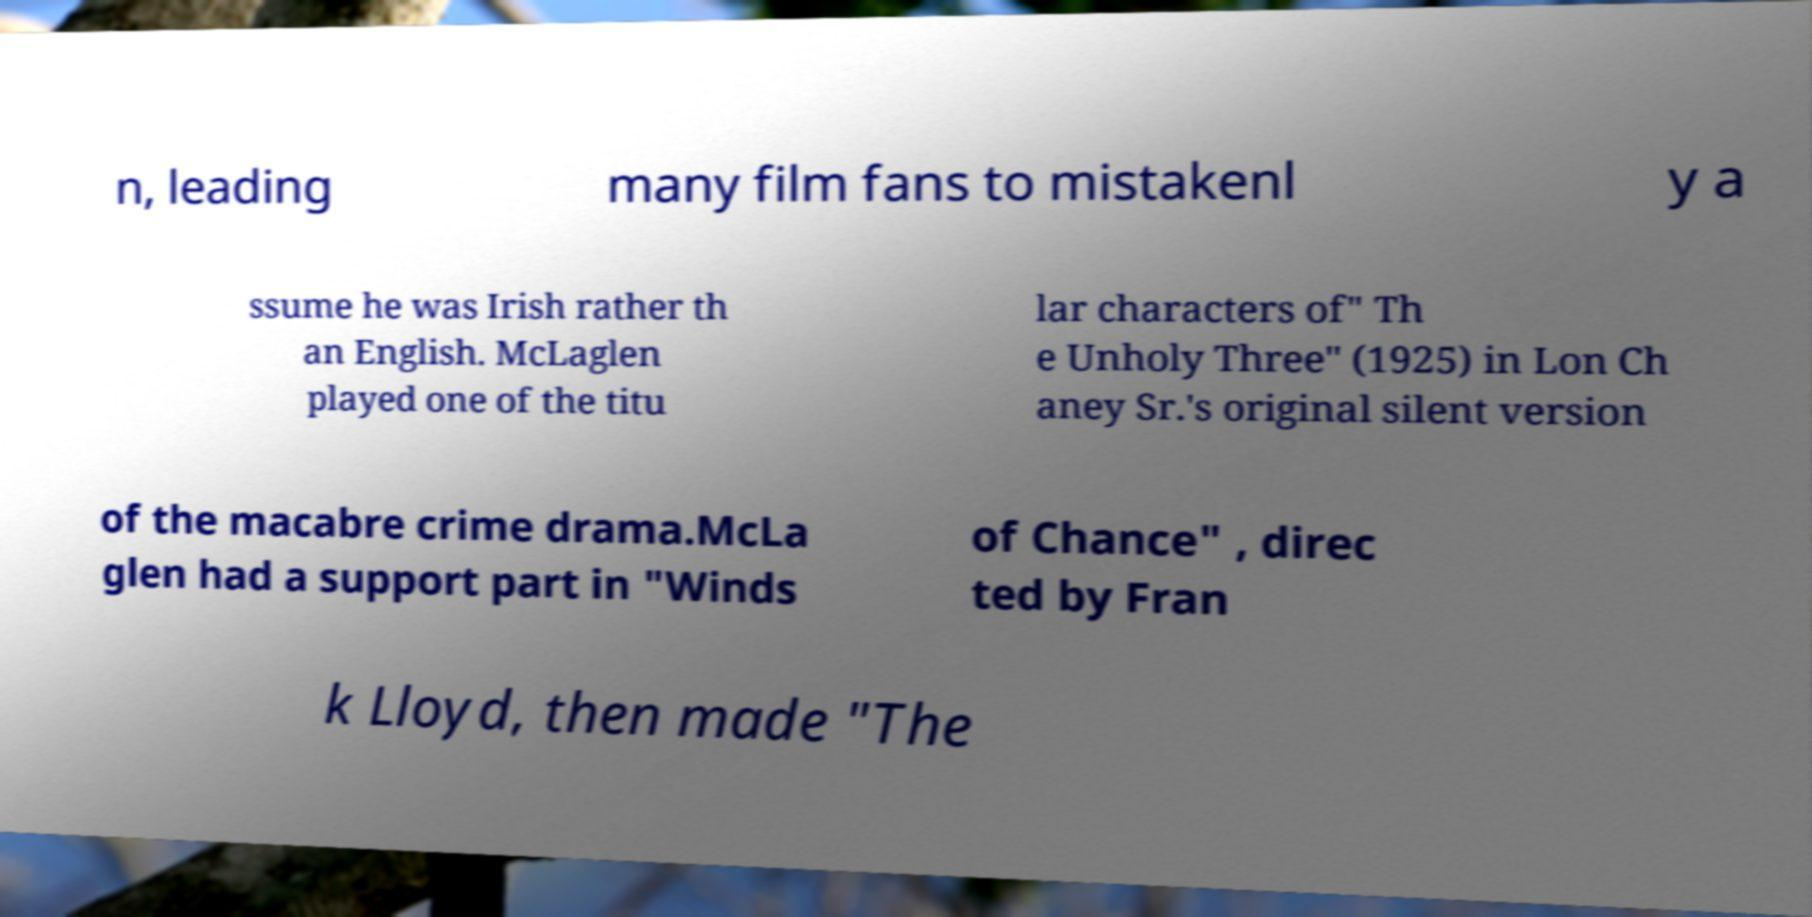There's text embedded in this image that I need extracted. Can you transcribe it verbatim? n, leading many film fans to mistakenl y a ssume he was Irish rather th an English. McLaglen played one of the titu lar characters of" Th e Unholy Three" (1925) in Lon Ch aney Sr.'s original silent version of the macabre crime drama.McLa glen had a support part in "Winds of Chance" , direc ted by Fran k Lloyd, then made "The 